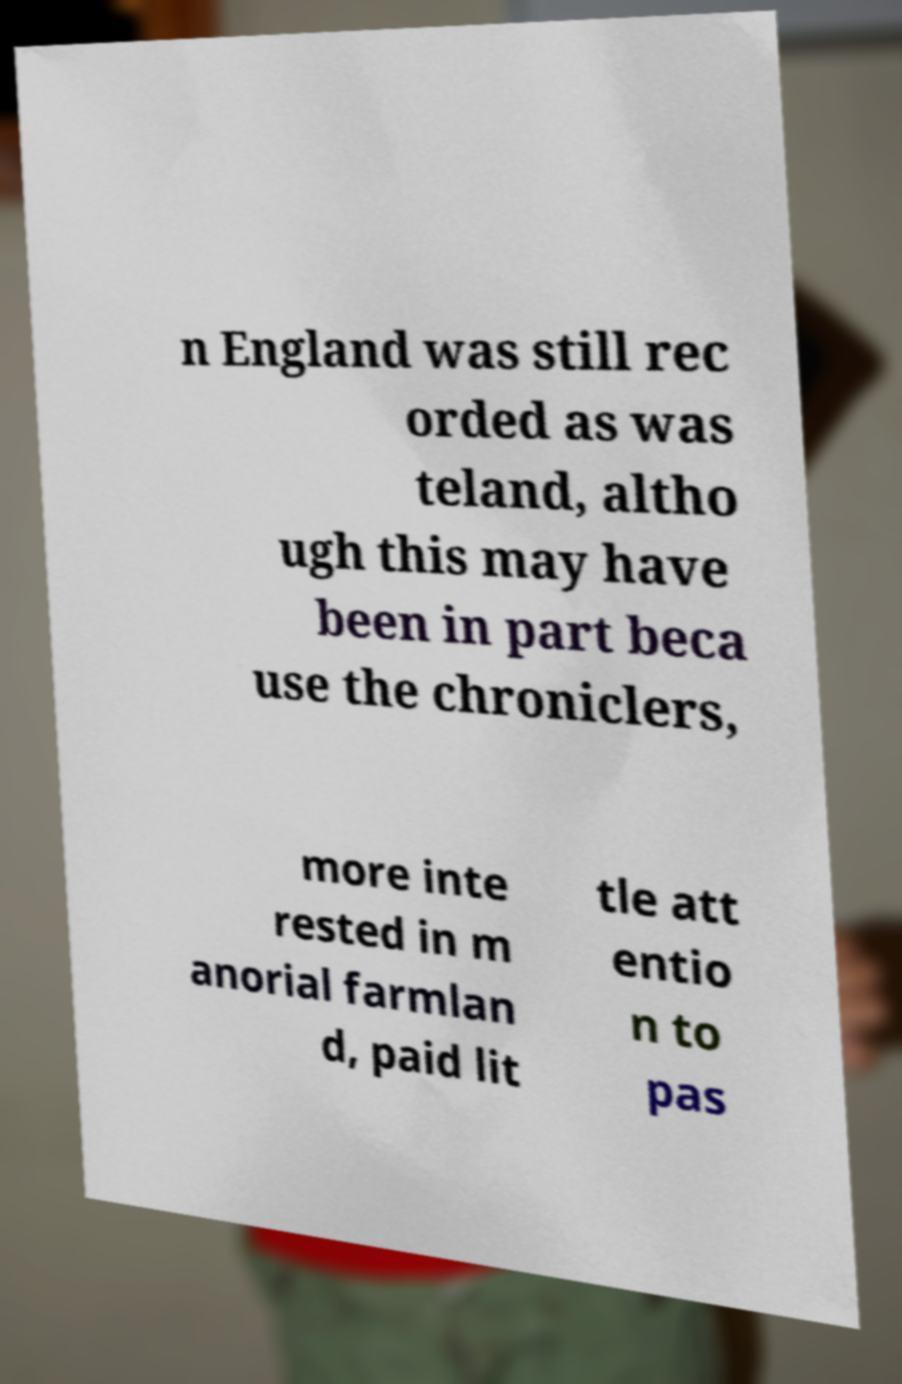For documentation purposes, I need the text within this image transcribed. Could you provide that? n England was still rec orded as was teland, altho ugh this may have been in part beca use the chroniclers, more inte rested in m anorial farmlan d, paid lit tle att entio n to pas 